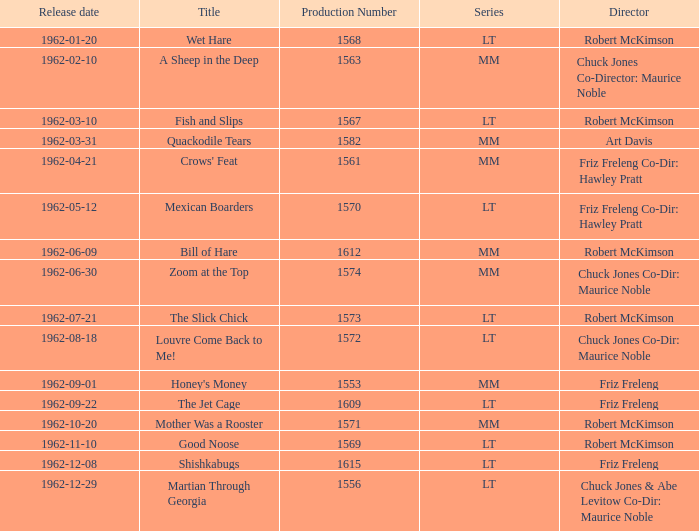What date was Wet Hare, directed by Robert McKimson, released? 1962-01-20. 